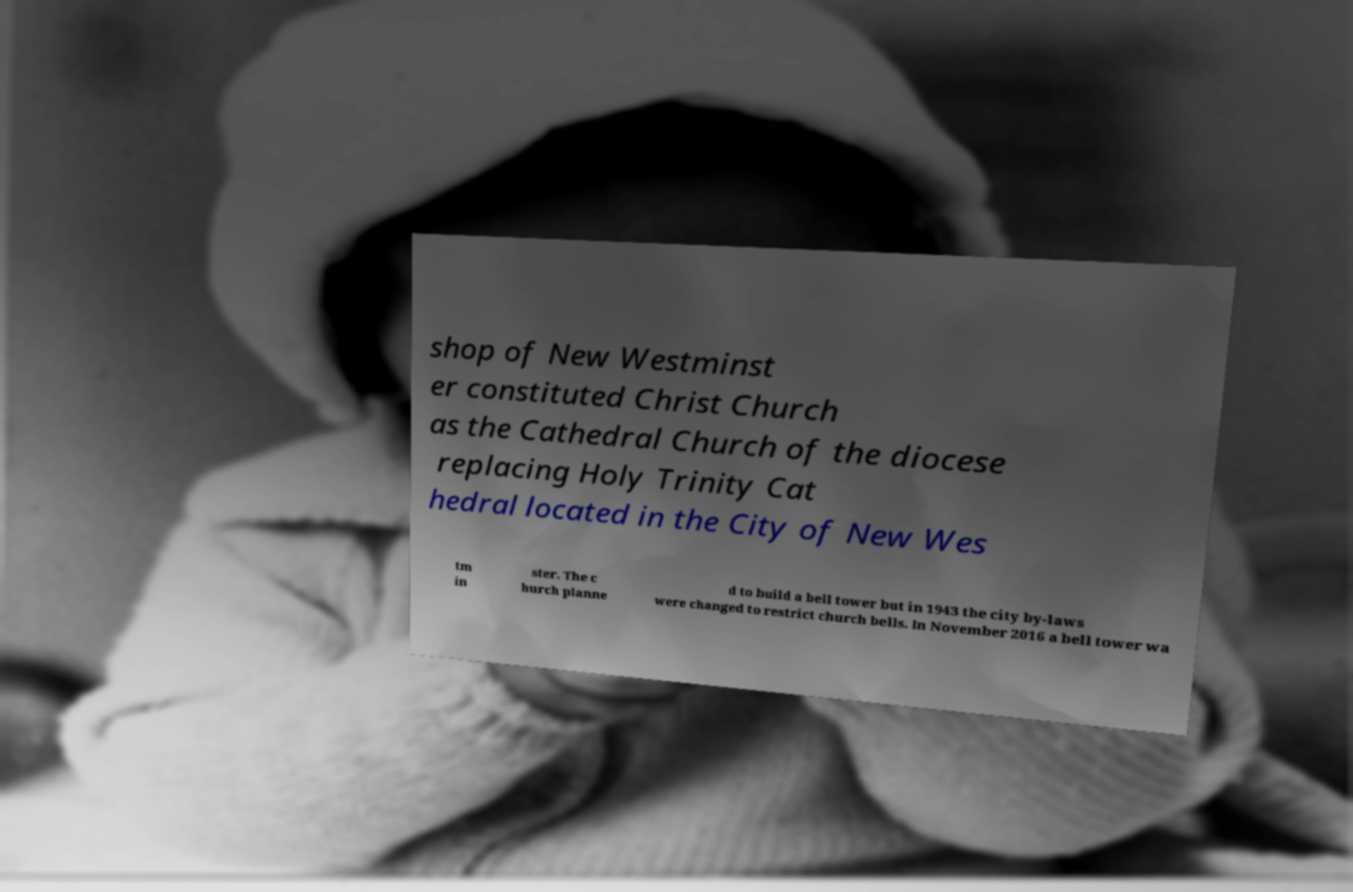Can you accurately transcribe the text from the provided image for me? shop of New Westminst er constituted Christ Church as the Cathedral Church of the diocese replacing Holy Trinity Cat hedral located in the City of New Wes tm in ster. The c hurch planne d to build a bell tower but in 1943 the city by-laws were changed to restrict church bells. In November 2016 a bell tower wa 